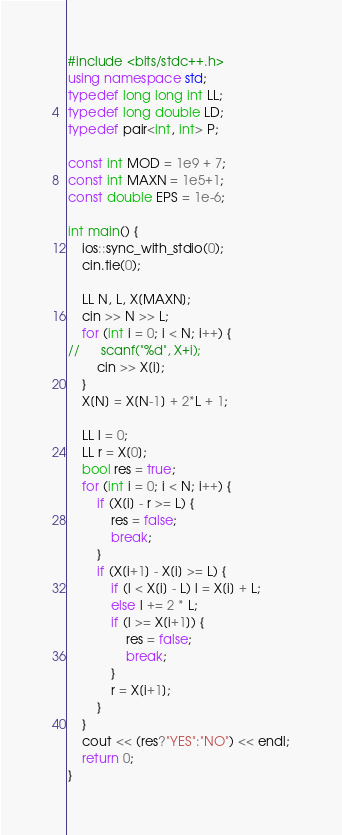<code> <loc_0><loc_0><loc_500><loc_500><_C++_>#include <bits/stdc++.h>
using namespace std;
typedef long long int LL;
typedef long double LD;
typedef pair<int, int> P;

const int MOD = 1e9 + 7;
const int MAXN = 1e5+1;
const double EPS = 1e-6;

int main() {
	ios::sync_with_stdio(0);
	cin.tie(0);

	LL N, L, X[MAXN];
	cin >> N >> L;
	for (int i = 0; i < N; i++) {
//		scanf("%d", X+i);
		cin >> X[i];
	}
	X[N] = X[N-1] + 2*L + 1;

	LL l = 0;
	LL r = X[0];
	bool res = true;
	for (int i = 0; i < N; i++) {
		if (X[i] - r >= L) {
			res = false;
			break;				
		}
		if (X[i+1] - X[i] >= L) {
			if (l < X[i] - L) l = X[i] + L;
			else l += 2 * L;
			if (l >= X[i+1]) {
				res = false;
				break;
			}
			r = X[i+1];
		}
	}
	cout << (res?"YES":"NO") << endl;
	return 0;
}</code> 